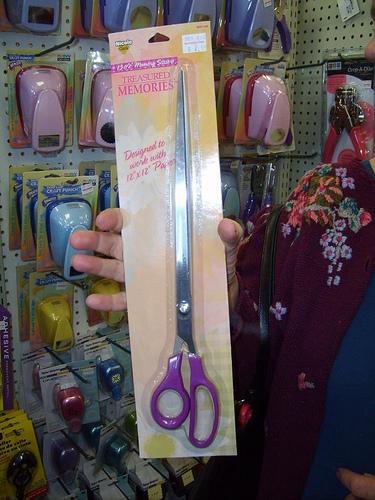Are the scissors long?
Answer briefly. Yes. What is the theme of the items in this image?
Quick response, please. Scissors. What section of the store is this found in?
Quick response, please. Crafts. What color are the scissor handles?
Short answer required. Purple. 